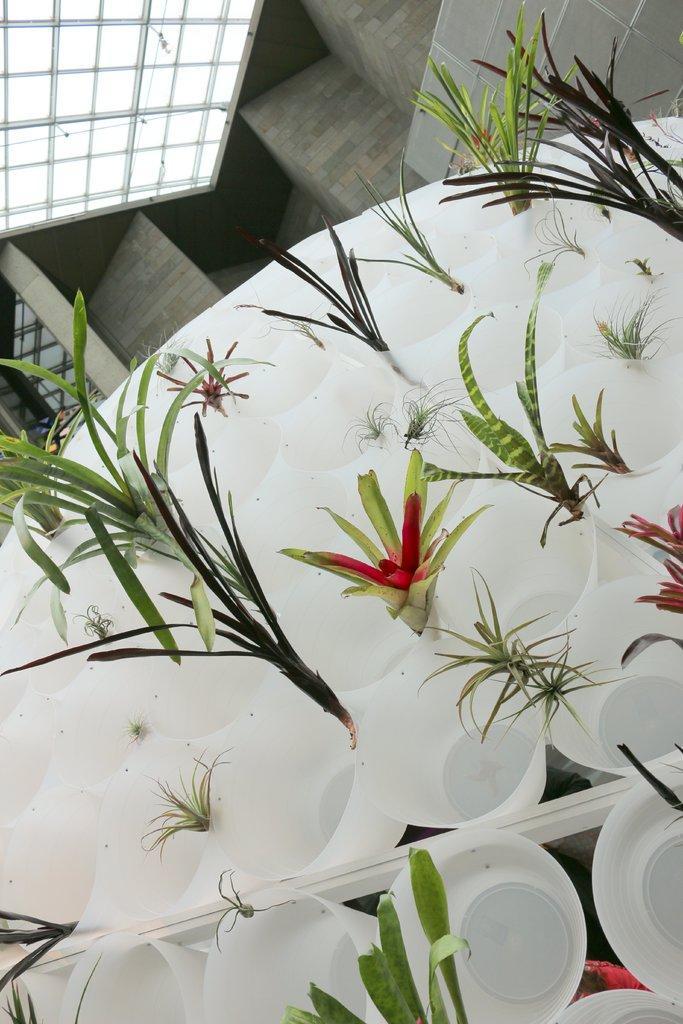Please provide a concise description of this image. In this image I can see number of white colored cups and in them I can see few plants which are green, red and pink in color. In the background I can see the wall and the ceiling. 